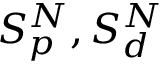Convert formula to latex. <formula><loc_0><loc_0><loc_500><loc_500>S _ { p } ^ { N } , S _ { d } ^ { N }</formula> 